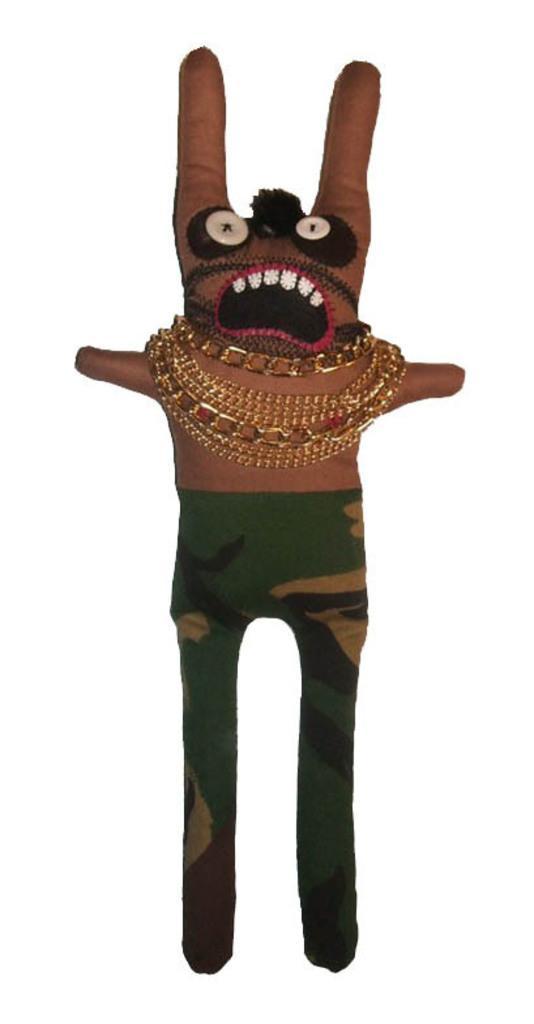In one or two sentences, can you explain what this image depicts? In the picture we can see a doll which is brown in color with a green color trouser with some designs on it and to the doll we can see some gold chains. 